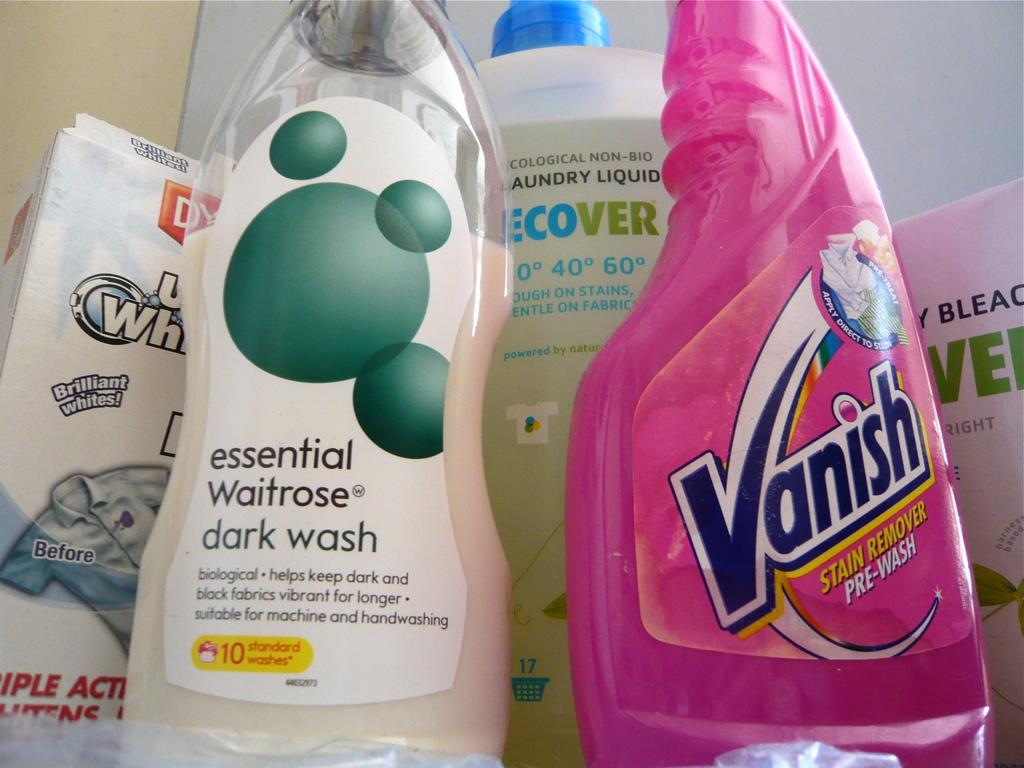<image>
Offer a succinct explanation of the picture presented. A pink bottle of Vanish sits next to a bottle of dark wash. 